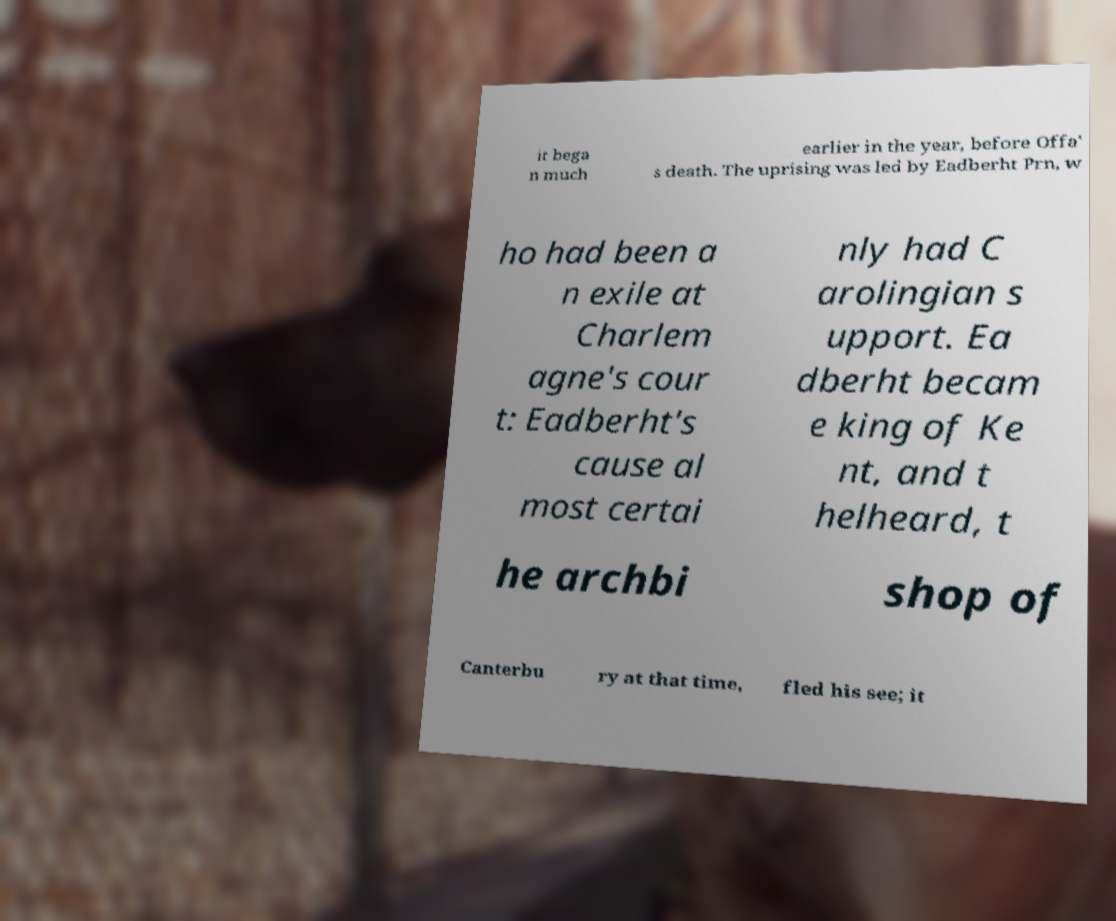Please read and relay the text visible in this image. What does it say? it bega n much earlier in the year, before Offa' s death. The uprising was led by Eadberht Prn, w ho had been a n exile at Charlem agne's cour t: Eadberht's cause al most certai nly had C arolingian s upport. Ea dberht becam e king of Ke nt, and t helheard, t he archbi shop of Canterbu ry at that time, fled his see; it 